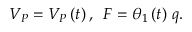<formula> <loc_0><loc_0><loc_500><loc_500>V _ { P } = V _ { P } \left ( t \right ) , \, F = \theta _ { 1 } \left ( t \right ) \, q .</formula> 